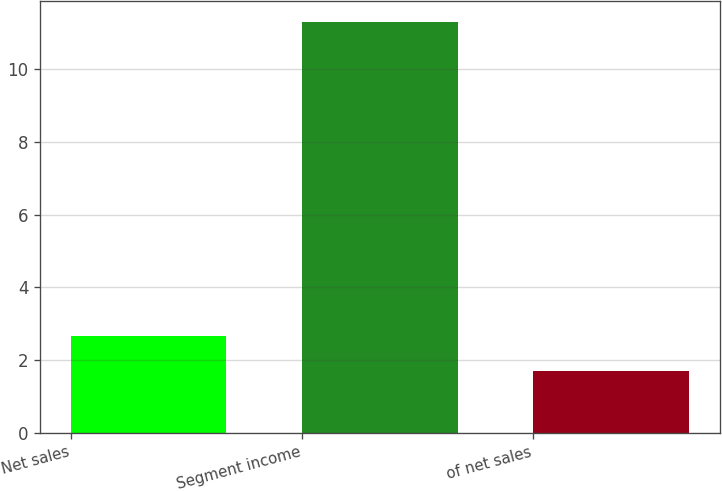<chart> <loc_0><loc_0><loc_500><loc_500><bar_chart><fcel>Net sales<fcel>Segment income<fcel>of net sales<nl><fcel>2.66<fcel>11.3<fcel>1.7<nl></chart> 